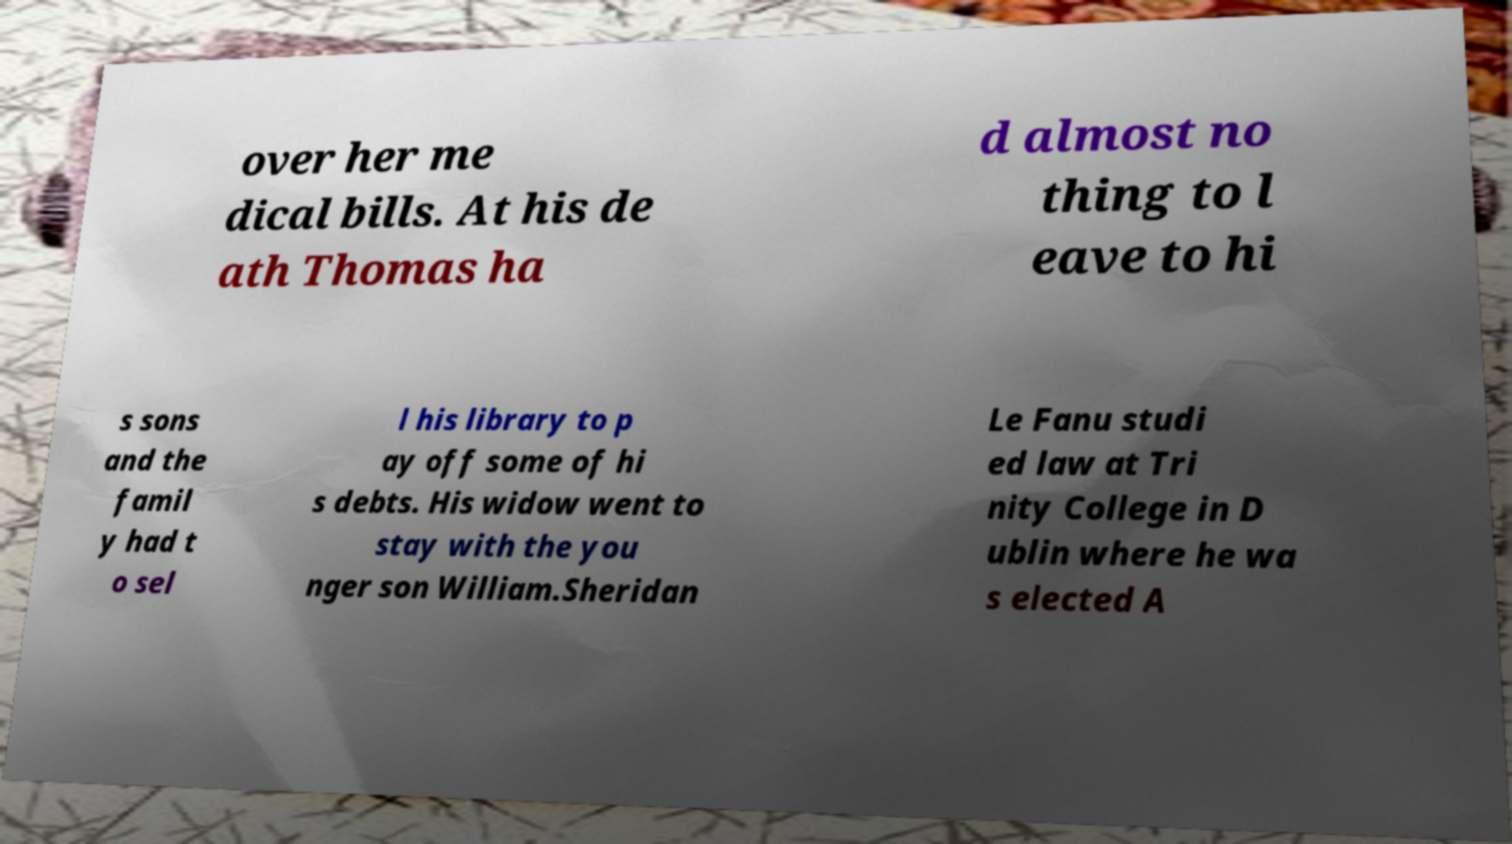There's text embedded in this image that I need extracted. Can you transcribe it verbatim? over her me dical bills. At his de ath Thomas ha d almost no thing to l eave to hi s sons and the famil y had t o sel l his library to p ay off some of hi s debts. His widow went to stay with the you nger son William.Sheridan Le Fanu studi ed law at Tri nity College in D ublin where he wa s elected A 